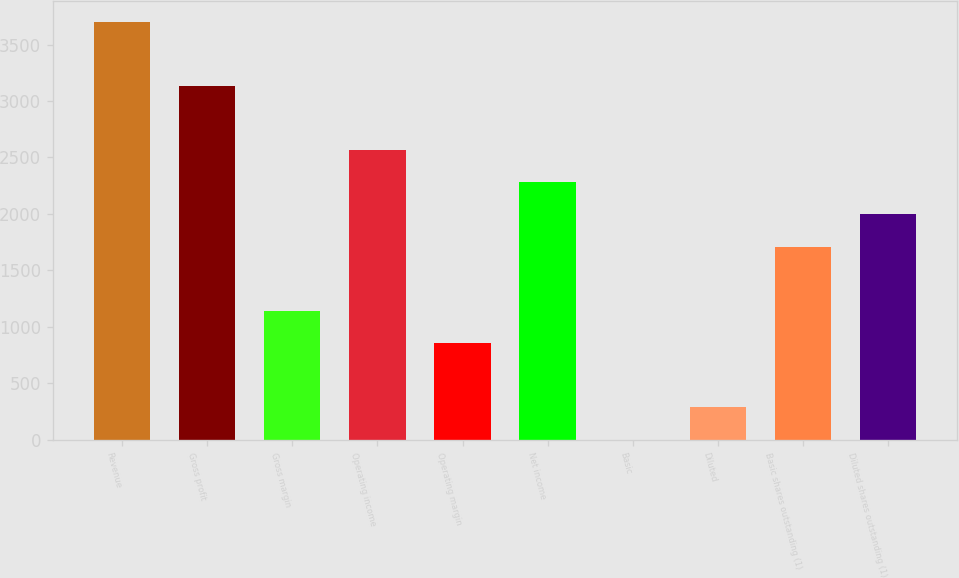Convert chart. <chart><loc_0><loc_0><loc_500><loc_500><bar_chart><fcel>Revenue<fcel>Gross profit<fcel>Gross margin<fcel>Operating income<fcel>Operating margin<fcel>Net income<fcel>Basic<fcel>Diluted<fcel>Basic shares outstanding (1)<fcel>Diluted shares outstanding (1)<nl><fcel>3703.3<fcel>3133.78<fcel>1140.46<fcel>2564.26<fcel>855.7<fcel>2279.5<fcel>1.42<fcel>286.18<fcel>1709.98<fcel>1994.74<nl></chart> 